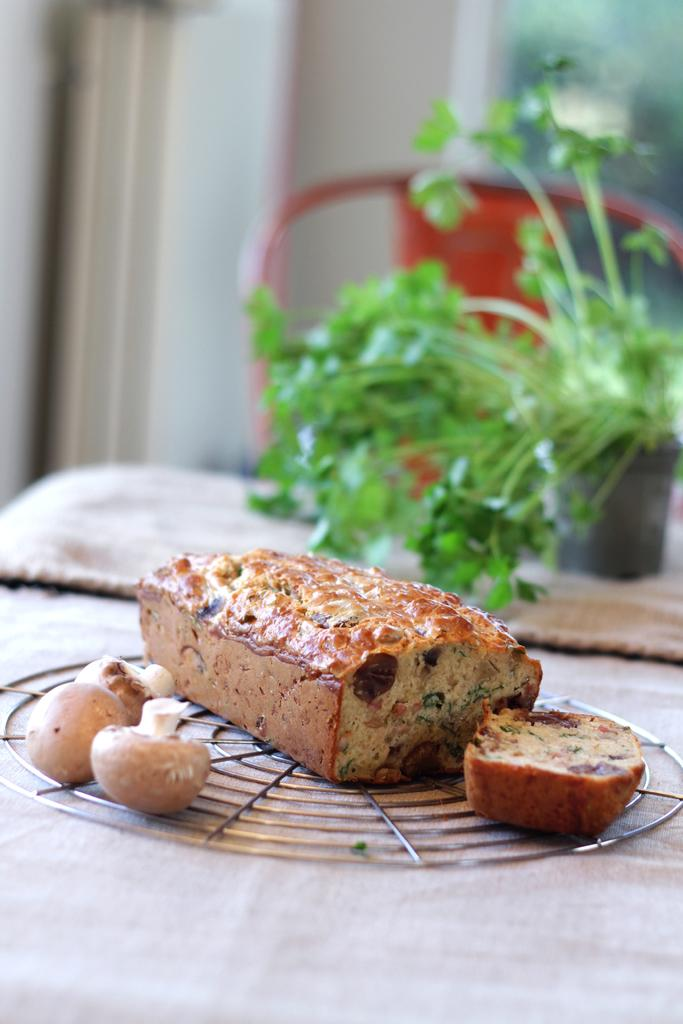What is the main object on the table in the image? There is a cake on a table in the image. What other items can be seen in the image besides the cake? There are mushrooms visible in the image. What can be seen in the background of the image? There is a plant and a chair in the background of the image. How many chickens are sitting on the cake in the image? There are no chickens present in the image; it features a cake, mushrooms, a plant, and a chair. What type of wax is used to decorate the cake in the image? There is no wax mentioned or visible in the image; it only shows a cake, mushrooms, a plant, and a chair. 